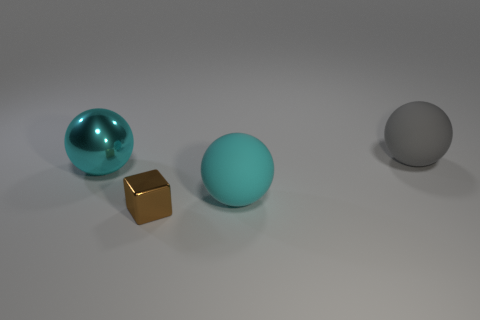Subtract all yellow cubes. Subtract all blue cylinders. How many cubes are left? 1 Add 1 green matte balls. How many objects exist? 5 Subtract all cubes. How many objects are left? 3 Subtract 0 purple cylinders. How many objects are left? 4 Subtract all large yellow metallic balls. Subtract all gray rubber things. How many objects are left? 3 Add 1 brown metal cubes. How many brown metal cubes are left? 2 Add 4 large cyan rubber things. How many large cyan rubber things exist? 5 